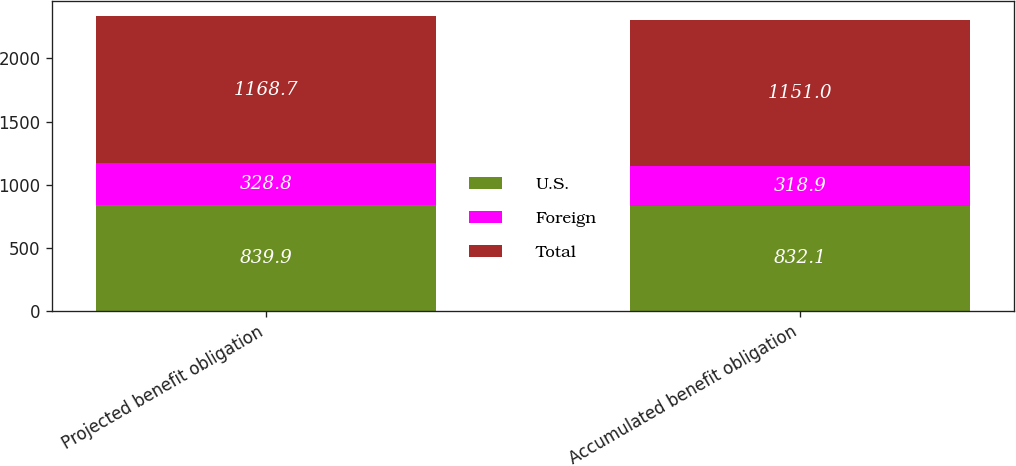<chart> <loc_0><loc_0><loc_500><loc_500><stacked_bar_chart><ecel><fcel>Projected benefit obligation<fcel>Accumulated benefit obligation<nl><fcel>U.S.<fcel>839.9<fcel>832.1<nl><fcel>Foreign<fcel>328.8<fcel>318.9<nl><fcel>Total<fcel>1168.7<fcel>1151<nl></chart> 